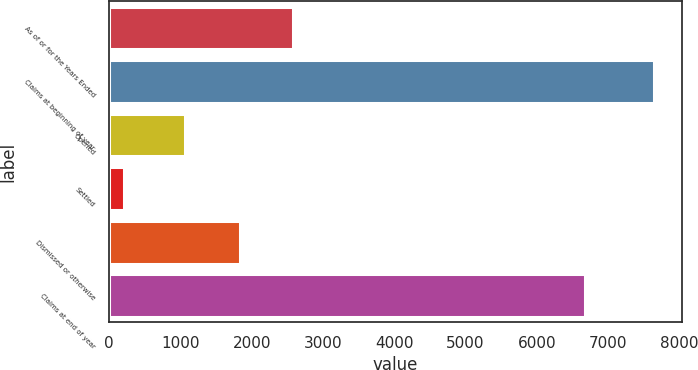<chart> <loc_0><loc_0><loc_500><loc_500><bar_chart><fcel>As of or for the Years Ended<fcel>Claims at beginning of year<fcel>Opened<fcel>Settled<fcel>Dismissed or otherwise<fcel>Claims at end of year<nl><fcel>2580.5<fcel>7652<fcel>1065<fcel>207<fcel>1836<fcel>6674<nl></chart> 